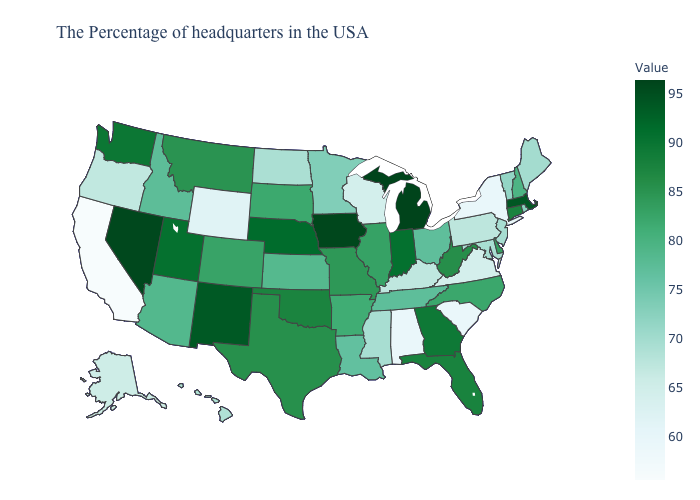Among the states that border Tennessee , does Arkansas have the highest value?
Be succinct. No. Which states hav the highest value in the West?
Be succinct. Nevada. Is the legend a continuous bar?
Short answer required. Yes. Does Michigan have the highest value in the USA?
Quick response, please. Yes. Does Ohio have the lowest value in the USA?
Quick response, please. No. 